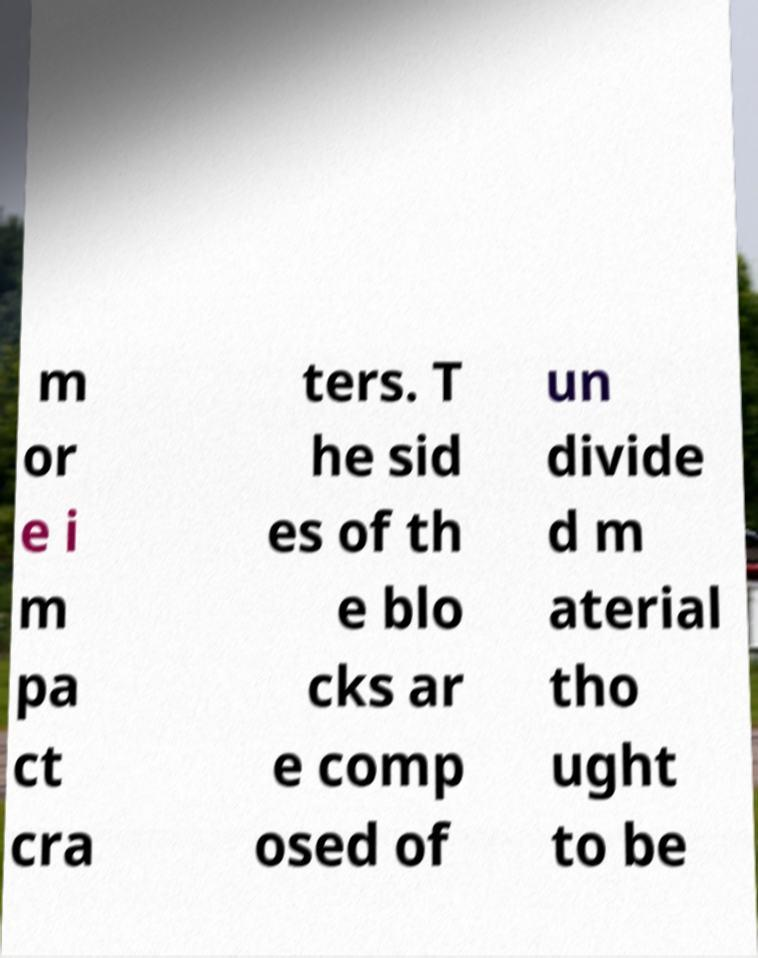Could you extract and type out the text from this image? m or e i m pa ct cra ters. T he sid es of th e blo cks ar e comp osed of un divide d m aterial tho ught to be 